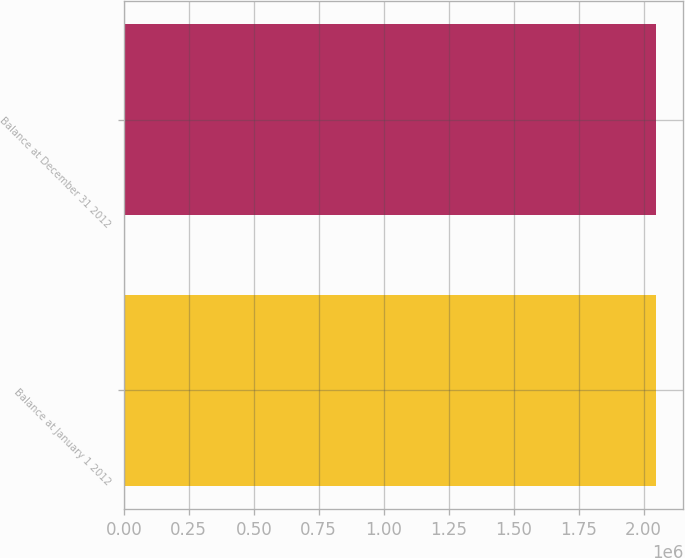Convert chart. <chart><loc_0><loc_0><loc_500><loc_500><bar_chart><fcel>Balance at January 1 2012<fcel>Balance at December 31 2012<nl><fcel>2.04752e+06<fcel>2.04931e+06<nl></chart> 